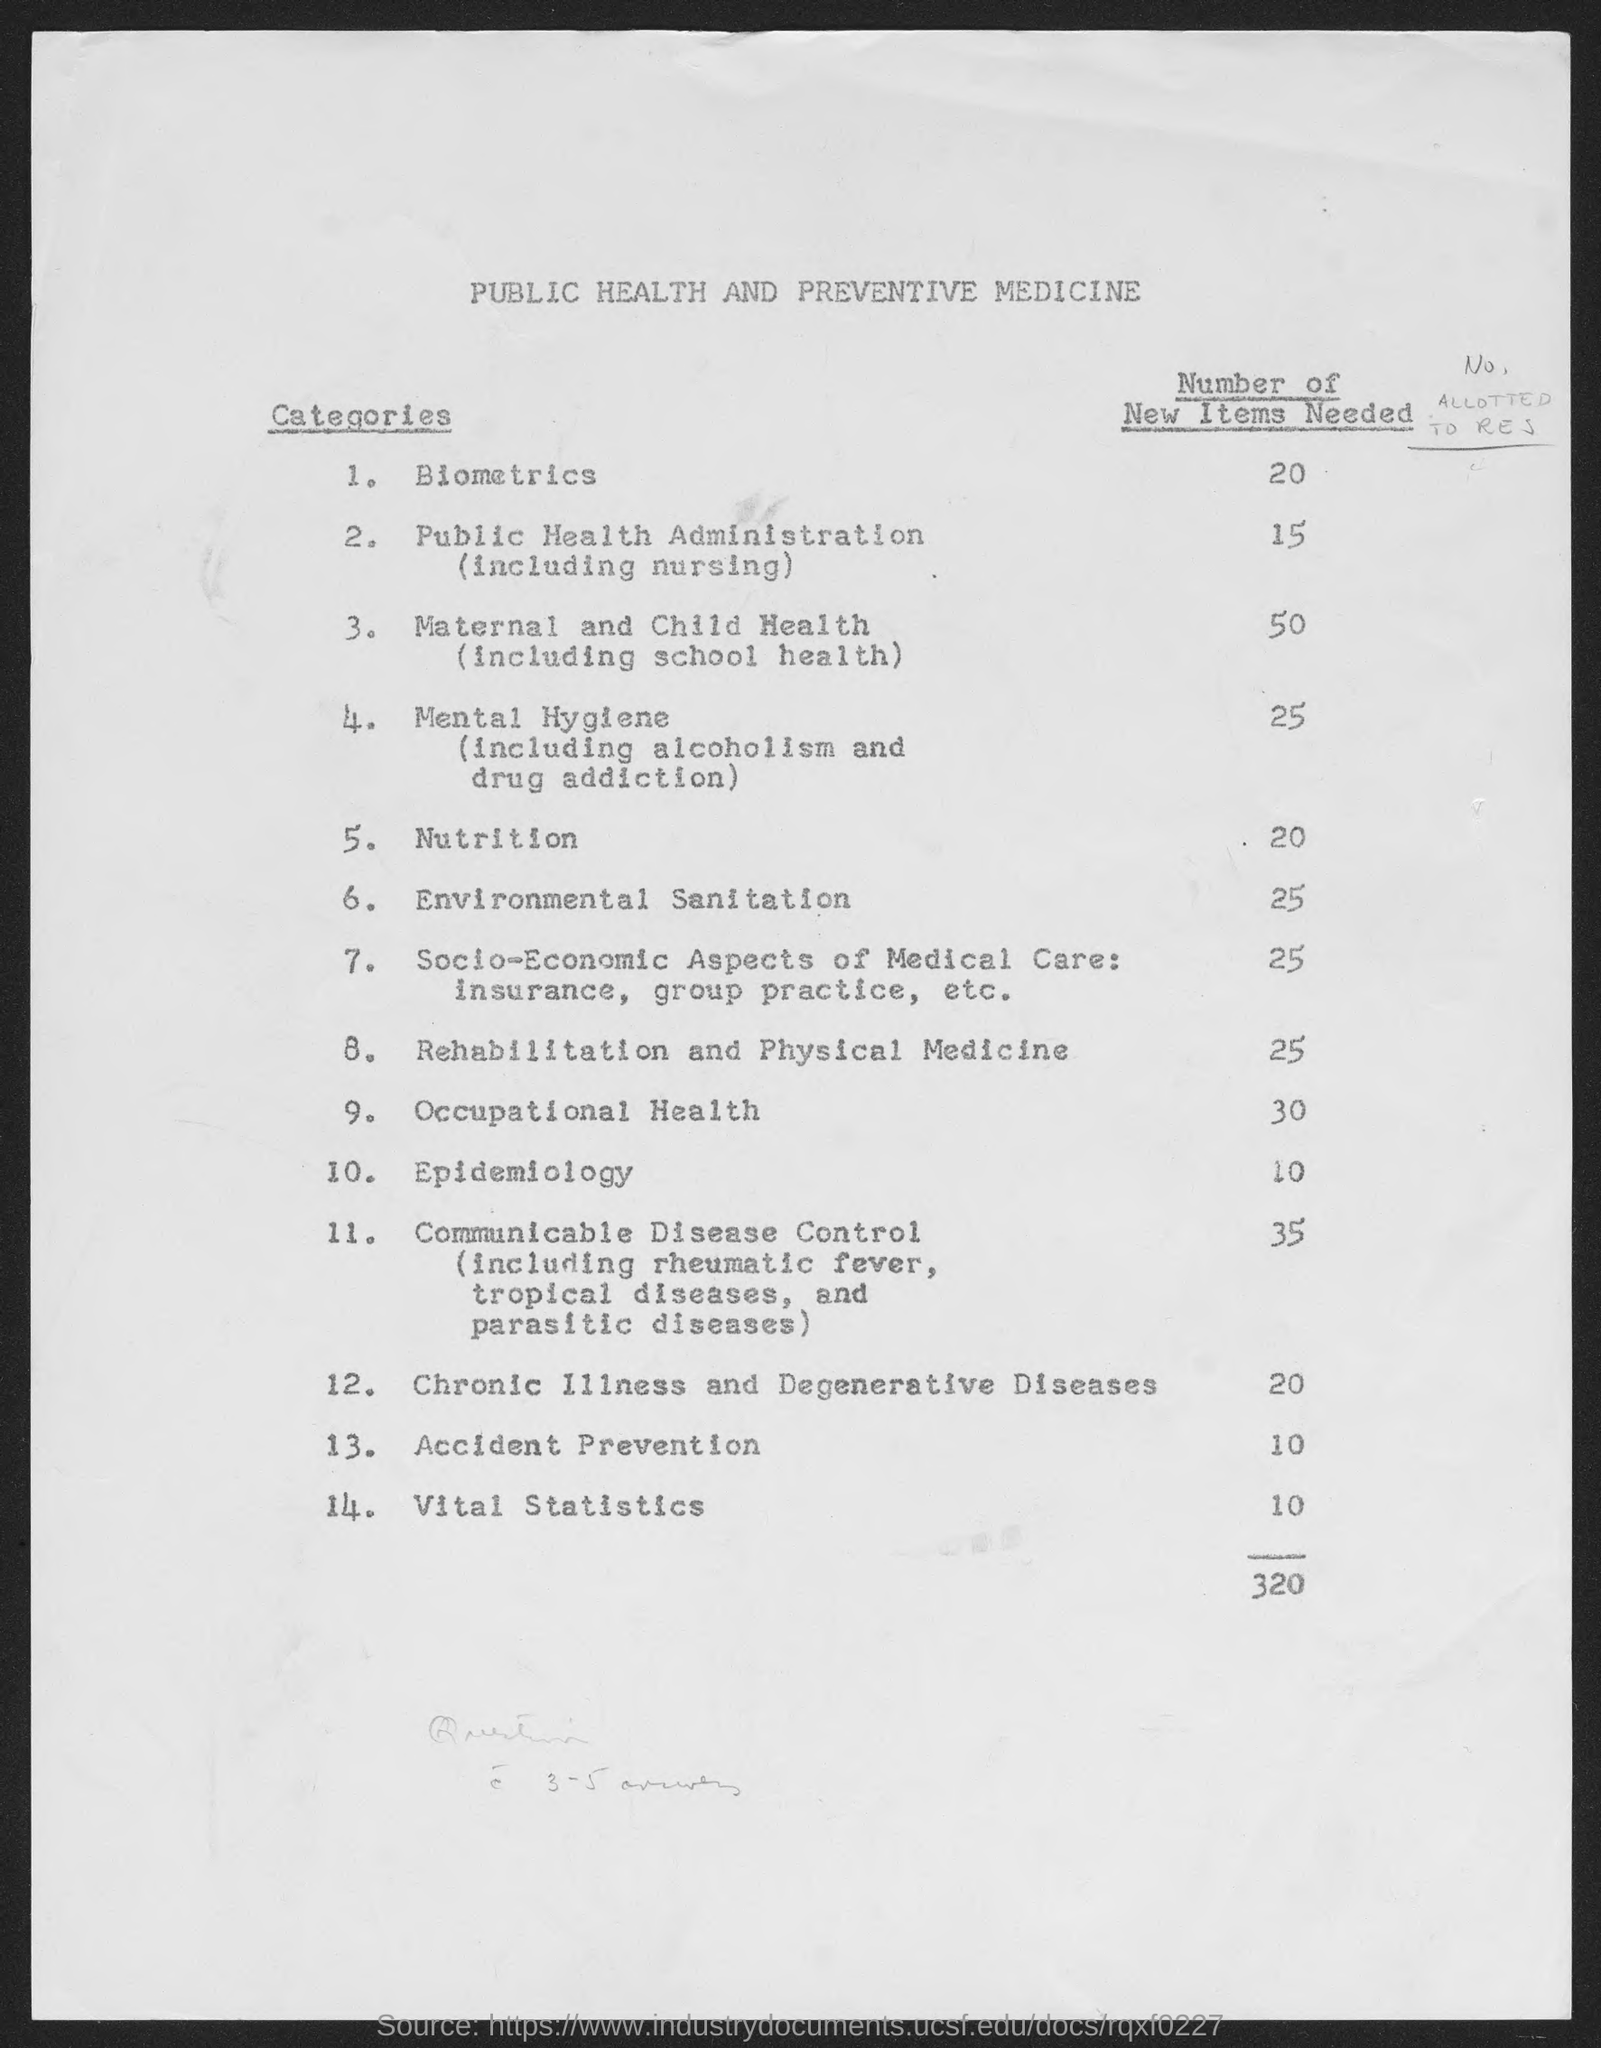Identify some key points in this picture. The total number of new items needed is 320. The document title is 'Public Health and Preventive Medicine.' What is the 14th Category? It is a vital statistics category that includes important data about an individual's vital functions and physical health. The number of new items required in Biometrics is 20.. 